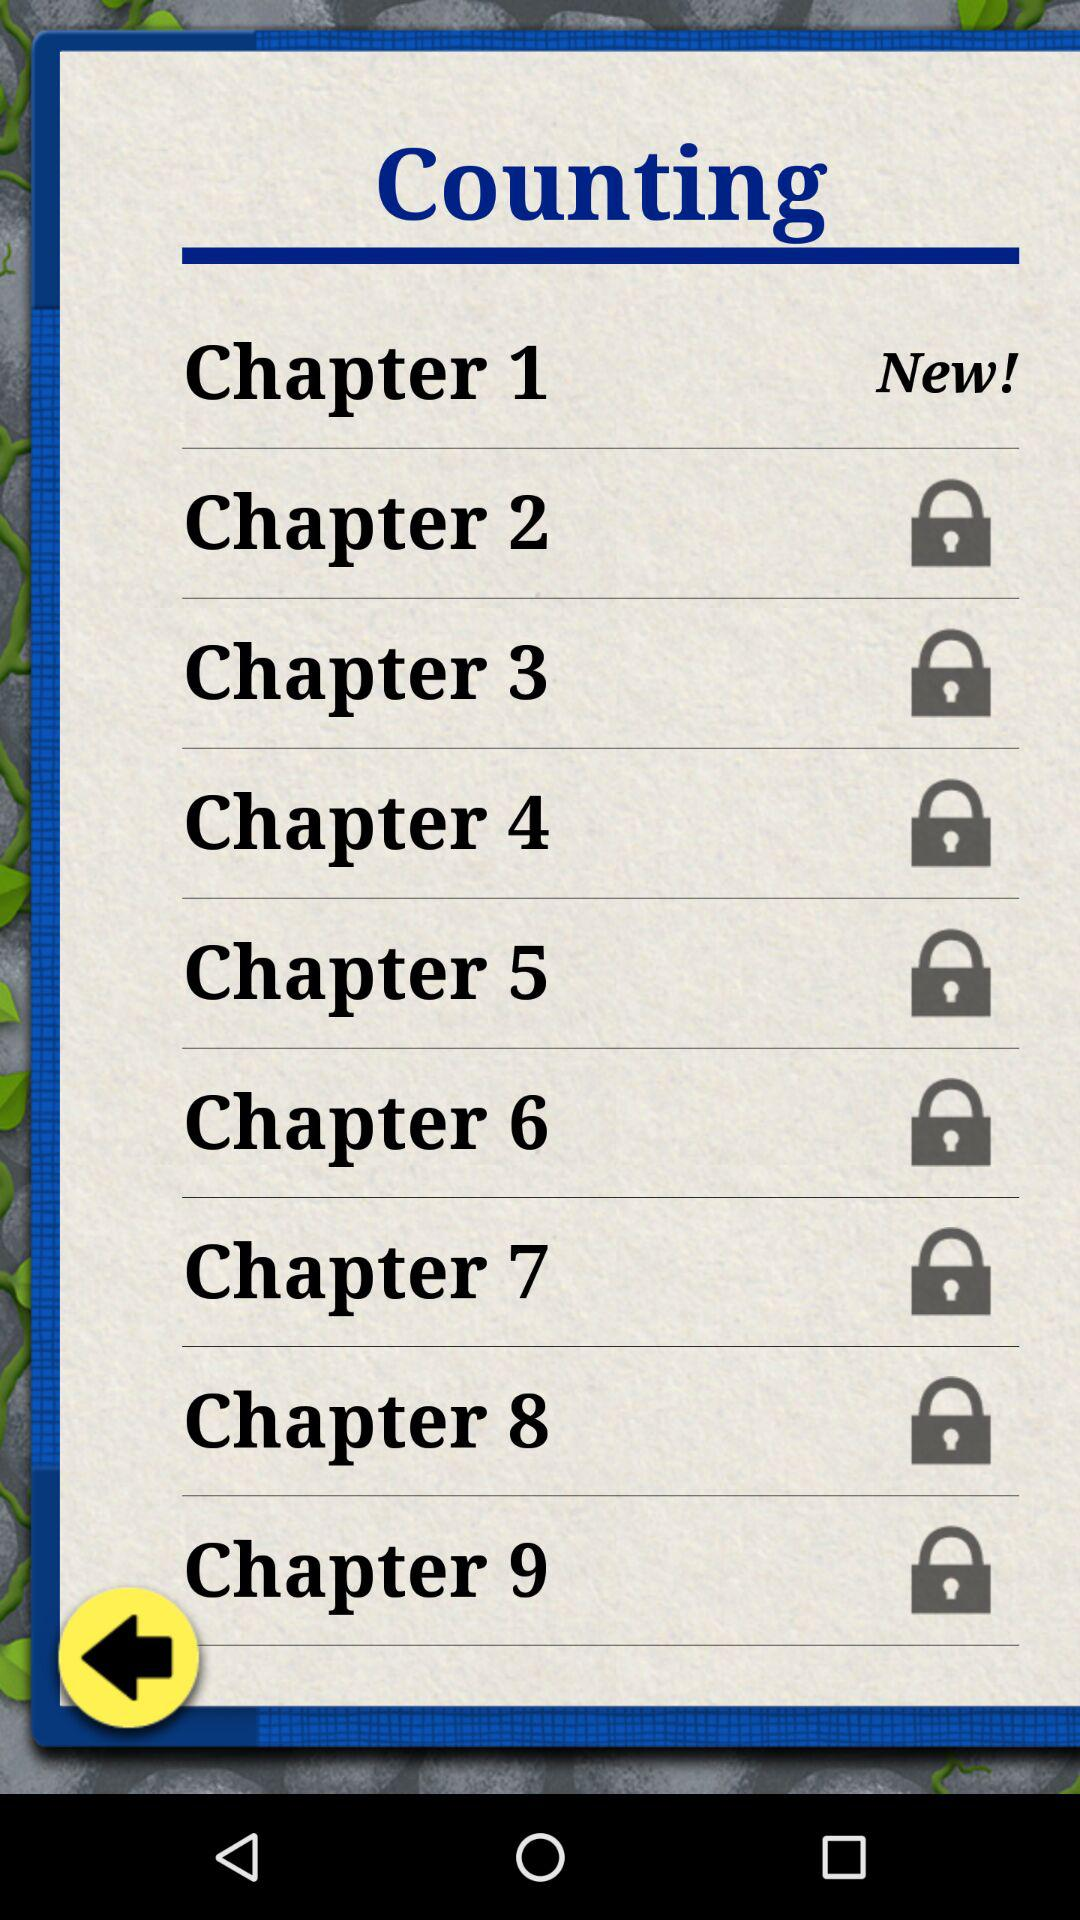How many chapters are there in total?
Answer the question using a single word or phrase. 9 